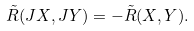Convert formula to latex. <formula><loc_0><loc_0><loc_500><loc_500>\tilde { R } ( J X , J Y ) = - \tilde { R } ( X , Y ) .</formula> 